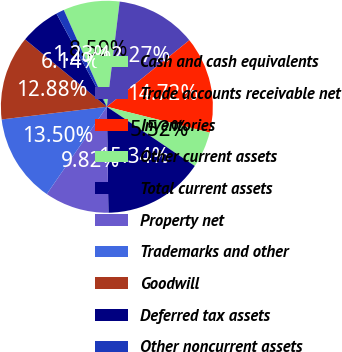Convert chart. <chart><loc_0><loc_0><loc_500><loc_500><pie_chart><fcel>Cash and cash equivalents<fcel>Trade accounts receivable net<fcel>Inventories<fcel>Other current assets<fcel>Total current assets<fcel>Property net<fcel>Trademarks and other<fcel>Goodwill<fcel>Deferred tax assets<fcel>Other noncurrent assets<nl><fcel>8.59%<fcel>12.27%<fcel>14.72%<fcel>5.52%<fcel>15.34%<fcel>9.82%<fcel>13.5%<fcel>12.88%<fcel>6.14%<fcel>1.23%<nl></chart> 